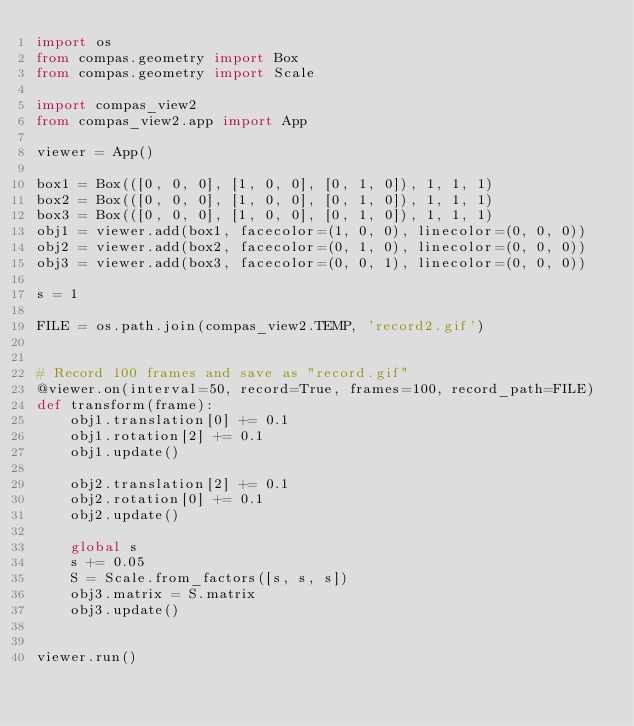<code> <loc_0><loc_0><loc_500><loc_500><_Python_>import os
from compas.geometry import Box
from compas.geometry import Scale

import compas_view2
from compas_view2.app import App

viewer = App()

box1 = Box(([0, 0, 0], [1, 0, 0], [0, 1, 0]), 1, 1, 1)
box2 = Box(([0, 0, 0], [1, 0, 0], [0, 1, 0]), 1, 1, 1)
box3 = Box(([0, 0, 0], [1, 0, 0], [0, 1, 0]), 1, 1, 1)
obj1 = viewer.add(box1, facecolor=(1, 0, 0), linecolor=(0, 0, 0))
obj2 = viewer.add(box2, facecolor=(0, 1, 0), linecolor=(0, 0, 0))
obj3 = viewer.add(box3, facecolor=(0, 0, 1), linecolor=(0, 0, 0))

s = 1

FILE = os.path.join(compas_view2.TEMP, 'record2.gif')


# Record 100 frames and save as "record.gif"
@viewer.on(interval=50, record=True, frames=100, record_path=FILE)
def transform(frame):
    obj1.translation[0] += 0.1
    obj1.rotation[2] += 0.1
    obj1.update()

    obj2.translation[2] += 0.1
    obj2.rotation[0] += 0.1
    obj2.update()

    global s
    s += 0.05
    S = Scale.from_factors([s, s, s])
    obj3.matrix = S.matrix
    obj3.update()


viewer.run()
</code> 